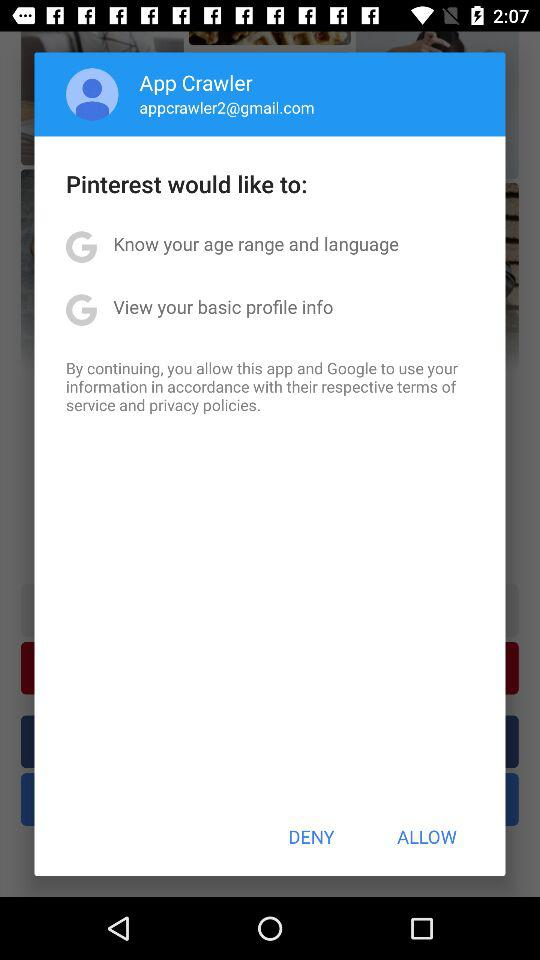How many permissions are requested?
Answer the question using a single word or phrase. 2 